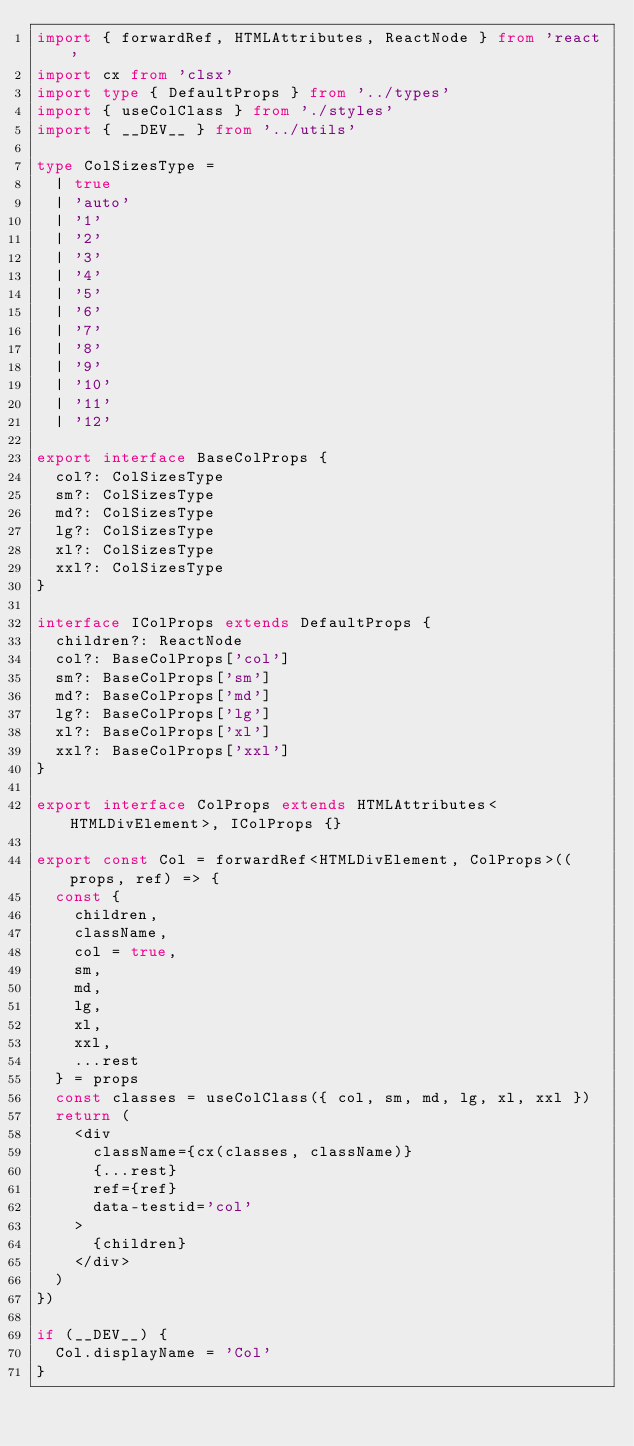<code> <loc_0><loc_0><loc_500><loc_500><_TypeScript_>import { forwardRef, HTMLAttributes, ReactNode } from 'react'
import cx from 'clsx'
import type { DefaultProps } from '../types'
import { useColClass } from './styles'
import { __DEV__ } from '../utils'

type ColSizesType =
  | true
  | 'auto'
  | '1'
  | '2'
  | '3'
  | '4'
  | '5'
  | '6'
  | '7'
  | '8'
  | '9'
  | '10'
  | '11'
  | '12'

export interface BaseColProps {
  col?: ColSizesType
  sm?: ColSizesType
  md?: ColSizesType
  lg?: ColSizesType
  xl?: ColSizesType
  xxl?: ColSizesType
}

interface IColProps extends DefaultProps {
  children?: ReactNode
  col?: BaseColProps['col']
  sm?: BaseColProps['sm']
  md?: BaseColProps['md']
  lg?: BaseColProps['lg']
  xl?: BaseColProps['xl']
  xxl?: BaseColProps['xxl']
}

export interface ColProps extends HTMLAttributes<HTMLDivElement>, IColProps {}

export const Col = forwardRef<HTMLDivElement, ColProps>((props, ref) => {
  const {
    children,
    className,
    col = true,
    sm,
    md,
    lg,
    xl,
    xxl,
    ...rest
  } = props
  const classes = useColClass({ col, sm, md, lg, xl, xxl })
  return (
    <div
      className={cx(classes, className)}
      {...rest}
      ref={ref}
      data-testid='col'
    >
      {children}
    </div>
  )
})

if (__DEV__) {
  Col.displayName = 'Col'
}
</code> 